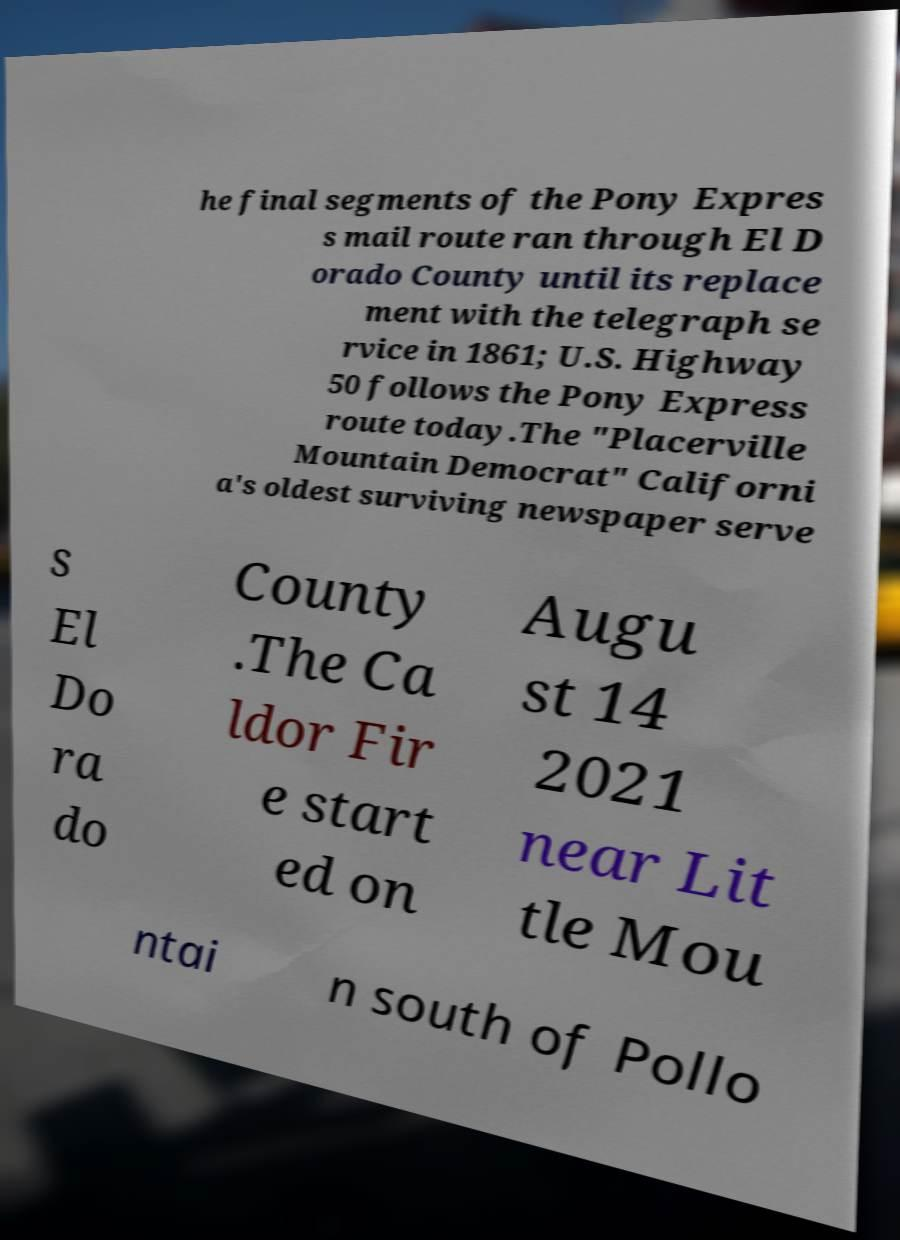Please identify and transcribe the text found in this image. he final segments of the Pony Expres s mail route ran through El D orado County until its replace ment with the telegraph se rvice in 1861; U.S. Highway 50 follows the Pony Express route today.The "Placerville Mountain Democrat" Californi a's oldest surviving newspaper serve s El Do ra do County .The Ca ldor Fir e start ed on Augu st 14 2021 near Lit tle Mou ntai n south of Pollo 